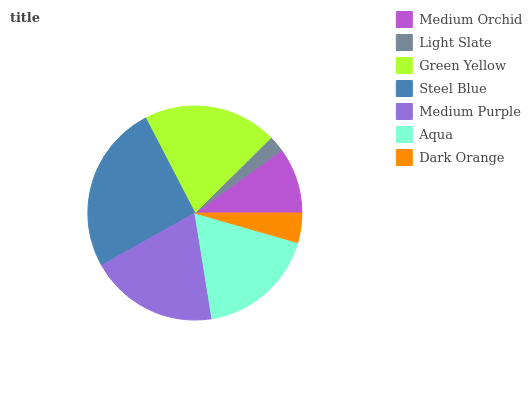Is Light Slate the minimum?
Answer yes or no. Yes. Is Steel Blue the maximum?
Answer yes or no. Yes. Is Green Yellow the minimum?
Answer yes or no. No. Is Green Yellow the maximum?
Answer yes or no. No. Is Green Yellow greater than Light Slate?
Answer yes or no. Yes. Is Light Slate less than Green Yellow?
Answer yes or no. Yes. Is Light Slate greater than Green Yellow?
Answer yes or no. No. Is Green Yellow less than Light Slate?
Answer yes or no. No. Is Aqua the high median?
Answer yes or no. Yes. Is Aqua the low median?
Answer yes or no. Yes. Is Green Yellow the high median?
Answer yes or no. No. Is Medium Orchid the low median?
Answer yes or no. No. 